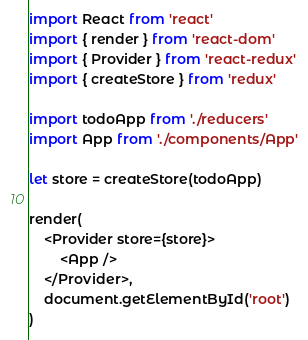Convert code to text. <code><loc_0><loc_0><loc_500><loc_500><_JavaScript_>import React from 'react'
import { render } from 'react-dom'
import { Provider } from 'react-redux'
import { createStore } from 'redux'

import todoApp from './reducers'
import App from './components/App'

let store = createStore(todoApp)

render(
	<Provider store={store}>
		<App />
	</Provider>,
	document.getElementById('root')
)</code> 